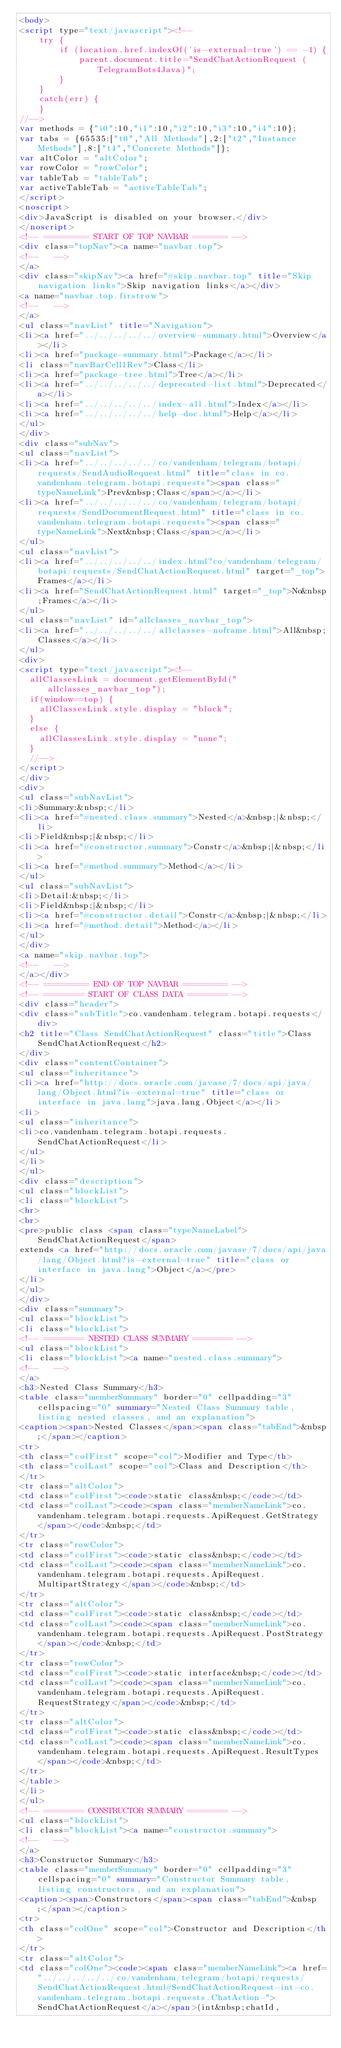<code> <loc_0><loc_0><loc_500><loc_500><_HTML_><body>
<script type="text/javascript"><!--
    try {
        if (location.href.indexOf('is-external=true') == -1) {
            parent.document.title="SendChatActionRequest (TelegramBots4Java)";
        }
    }
    catch(err) {
    }
//-->
var methods = {"i0":10,"i1":10,"i2":10,"i3":10,"i4":10};
var tabs = {65535:["t0","All Methods"],2:["t2","Instance Methods"],8:["t4","Concrete Methods"]};
var altColor = "altColor";
var rowColor = "rowColor";
var tableTab = "tableTab";
var activeTableTab = "activeTableTab";
</script>
<noscript>
<div>JavaScript is disabled on your browser.</div>
</noscript>
<!-- ========= START OF TOP NAVBAR ======= -->
<div class="topNav"><a name="navbar.top">
<!--   -->
</a>
<div class="skipNav"><a href="#skip.navbar.top" title="Skip navigation links">Skip navigation links</a></div>
<a name="navbar.top.firstrow">
<!--   -->
</a>
<ul class="navList" title="Navigation">
<li><a href="../../../../../overview-summary.html">Overview</a></li>
<li><a href="package-summary.html">Package</a></li>
<li class="navBarCell1Rev">Class</li>
<li><a href="package-tree.html">Tree</a></li>
<li><a href="../../../../../deprecated-list.html">Deprecated</a></li>
<li><a href="../../../../../index-all.html">Index</a></li>
<li><a href="../../../../../help-doc.html">Help</a></li>
</ul>
</div>
<div class="subNav">
<ul class="navList">
<li><a href="../../../../../co/vandenham/telegram/botapi/requests/SendAudioRequest.html" title="class in co.vandenham.telegram.botapi.requests"><span class="typeNameLink">Prev&nbsp;Class</span></a></li>
<li><a href="../../../../../co/vandenham/telegram/botapi/requests/SendDocumentRequest.html" title="class in co.vandenham.telegram.botapi.requests"><span class="typeNameLink">Next&nbsp;Class</span></a></li>
</ul>
<ul class="navList">
<li><a href="../../../../../index.html?co/vandenham/telegram/botapi/requests/SendChatActionRequest.html" target="_top">Frames</a></li>
<li><a href="SendChatActionRequest.html" target="_top">No&nbsp;Frames</a></li>
</ul>
<ul class="navList" id="allclasses_navbar_top">
<li><a href="../../../../../allclasses-noframe.html">All&nbsp;Classes</a></li>
</ul>
<div>
<script type="text/javascript"><!--
  allClassesLink = document.getElementById("allclasses_navbar_top");
  if(window==top) {
    allClassesLink.style.display = "block";
  }
  else {
    allClassesLink.style.display = "none";
  }
  //-->
</script>
</div>
<div>
<ul class="subNavList">
<li>Summary:&nbsp;</li>
<li><a href="#nested.class.summary">Nested</a>&nbsp;|&nbsp;</li>
<li>Field&nbsp;|&nbsp;</li>
<li><a href="#constructor.summary">Constr</a>&nbsp;|&nbsp;</li>
<li><a href="#method.summary">Method</a></li>
</ul>
<ul class="subNavList">
<li>Detail:&nbsp;</li>
<li>Field&nbsp;|&nbsp;</li>
<li><a href="#constructor.detail">Constr</a>&nbsp;|&nbsp;</li>
<li><a href="#method.detail">Method</a></li>
</ul>
</div>
<a name="skip.navbar.top">
<!--   -->
</a></div>
<!-- ========= END OF TOP NAVBAR ========= -->
<!-- ======== START OF CLASS DATA ======== -->
<div class="header">
<div class="subTitle">co.vandenham.telegram.botapi.requests</div>
<h2 title="Class SendChatActionRequest" class="title">Class SendChatActionRequest</h2>
</div>
<div class="contentContainer">
<ul class="inheritance">
<li><a href="http://docs.oracle.com/javase/7/docs/api/java/lang/Object.html?is-external=true" title="class or interface in java.lang">java.lang.Object</a></li>
<li>
<ul class="inheritance">
<li>co.vandenham.telegram.botapi.requests.SendChatActionRequest</li>
</ul>
</li>
</ul>
<div class="description">
<ul class="blockList">
<li class="blockList">
<hr>
<br>
<pre>public class <span class="typeNameLabel">SendChatActionRequest</span>
extends <a href="http://docs.oracle.com/javase/7/docs/api/java/lang/Object.html?is-external=true" title="class or interface in java.lang">Object</a></pre>
</li>
</ul>
</div>
<div class="summary">
<ul class="blockList">
<li class="blockList">
<!-- ======== NESTED CLASS SUMMARY ======== -->
<ul class="blockList">
<li class="blockList"><a name="nested.class.summary">
<!--   -->
</a>
<h3>Nested Class Summary</h3>
<table class="memberSummary" border="0" cellpadding="3" cellspacing="0" summary="Nested Class Summary table, listing nested classes, and an explanation">
<caption><span>Nested Classes</span><span class="tabEnd">&nbsp;</span></caption>
<tr>
<th class="colFirst" scope="col">Modifier and Type</th>
<th class="colLast" scope="col">Class and Description</th>
</tr>
<tr class="altColor">
<td class="colFirst"><code>static class&nbsp;</code></td>
<td class="colLast"><code><span class="memberNameLink">co.vandenham.telegram.botapi.requests.ApiRequest.GetStrategy</span></code>&nbsp;</td>
</tr>
<tr class="rowColor">
<td class="colFirst"><code>static class&nbsp;</code></td>
<td class="colLast"><code><span class="memberNameLink">co.vandenham.telegram.botapi.requests.ApiRequest.MultipartStrategy</span></code>&nbsp;</td>
</tr>
<tr class="altColor">
<td class="colFirst"><code>static class&nbsp;</code></td>
<td class="colLast"><code><span class="memberNameLink">co.vandenham.telegram.botapi.requests.ApiRequest.PostStrategy</span></code>&nbsp;</td>
</tr>
<tr class="rowColor">
<td class="colFirst"><code>static interface&nbsp;</code></td>
<td class="colLast"><code><span class="memberNameLink">co.vandenham.telegram.botapi.requests.ApiRequest.RequestStrategy</span></code>&nbsp;</td>
</tr>
<tr class="altColor">
<td class="colFirst"><code>static class&nbsp;</code></td>
<td class="colLast"><code><span class="memberNameLink">co.vandenham.telegram.botapi.requests.ApiRequest.ResultTypes</span></code>&nbsp;</td>
</tr>
</table>
</li>
</ul>
<!-- ======== CONSTRUCTOR SUMMARY ======== -->
<ul class="blockList">
<li class="blockList"><a name="constructor.summary">
<!--   -->
</a>
<h3>Constructor Summary</h3>
<table class="memberSummary" border="0" cellpadding="3" cellspacing="0" summary="Constructor Summary table, listing constructors, and an explanation">
<caption><span>Constructors</span><span class="tabEnd">&nbsp;</span></caption>
<tr>
<th class="colOne" scope="col">Constructor and Description</th>
</tr>
<tr class="altColor">
<td class="colOne"><code><span class="memberNameLink"><a href="../../../../../co/vandenham/telegram/botapi/requests/SendChatActionRequest.html#SendChatActionRequest-int-co.vandenham.telegram.botapi.requests.ChatAction-">SendChatActionRequest</a></span>(int&nbsp;chatId,</code> 